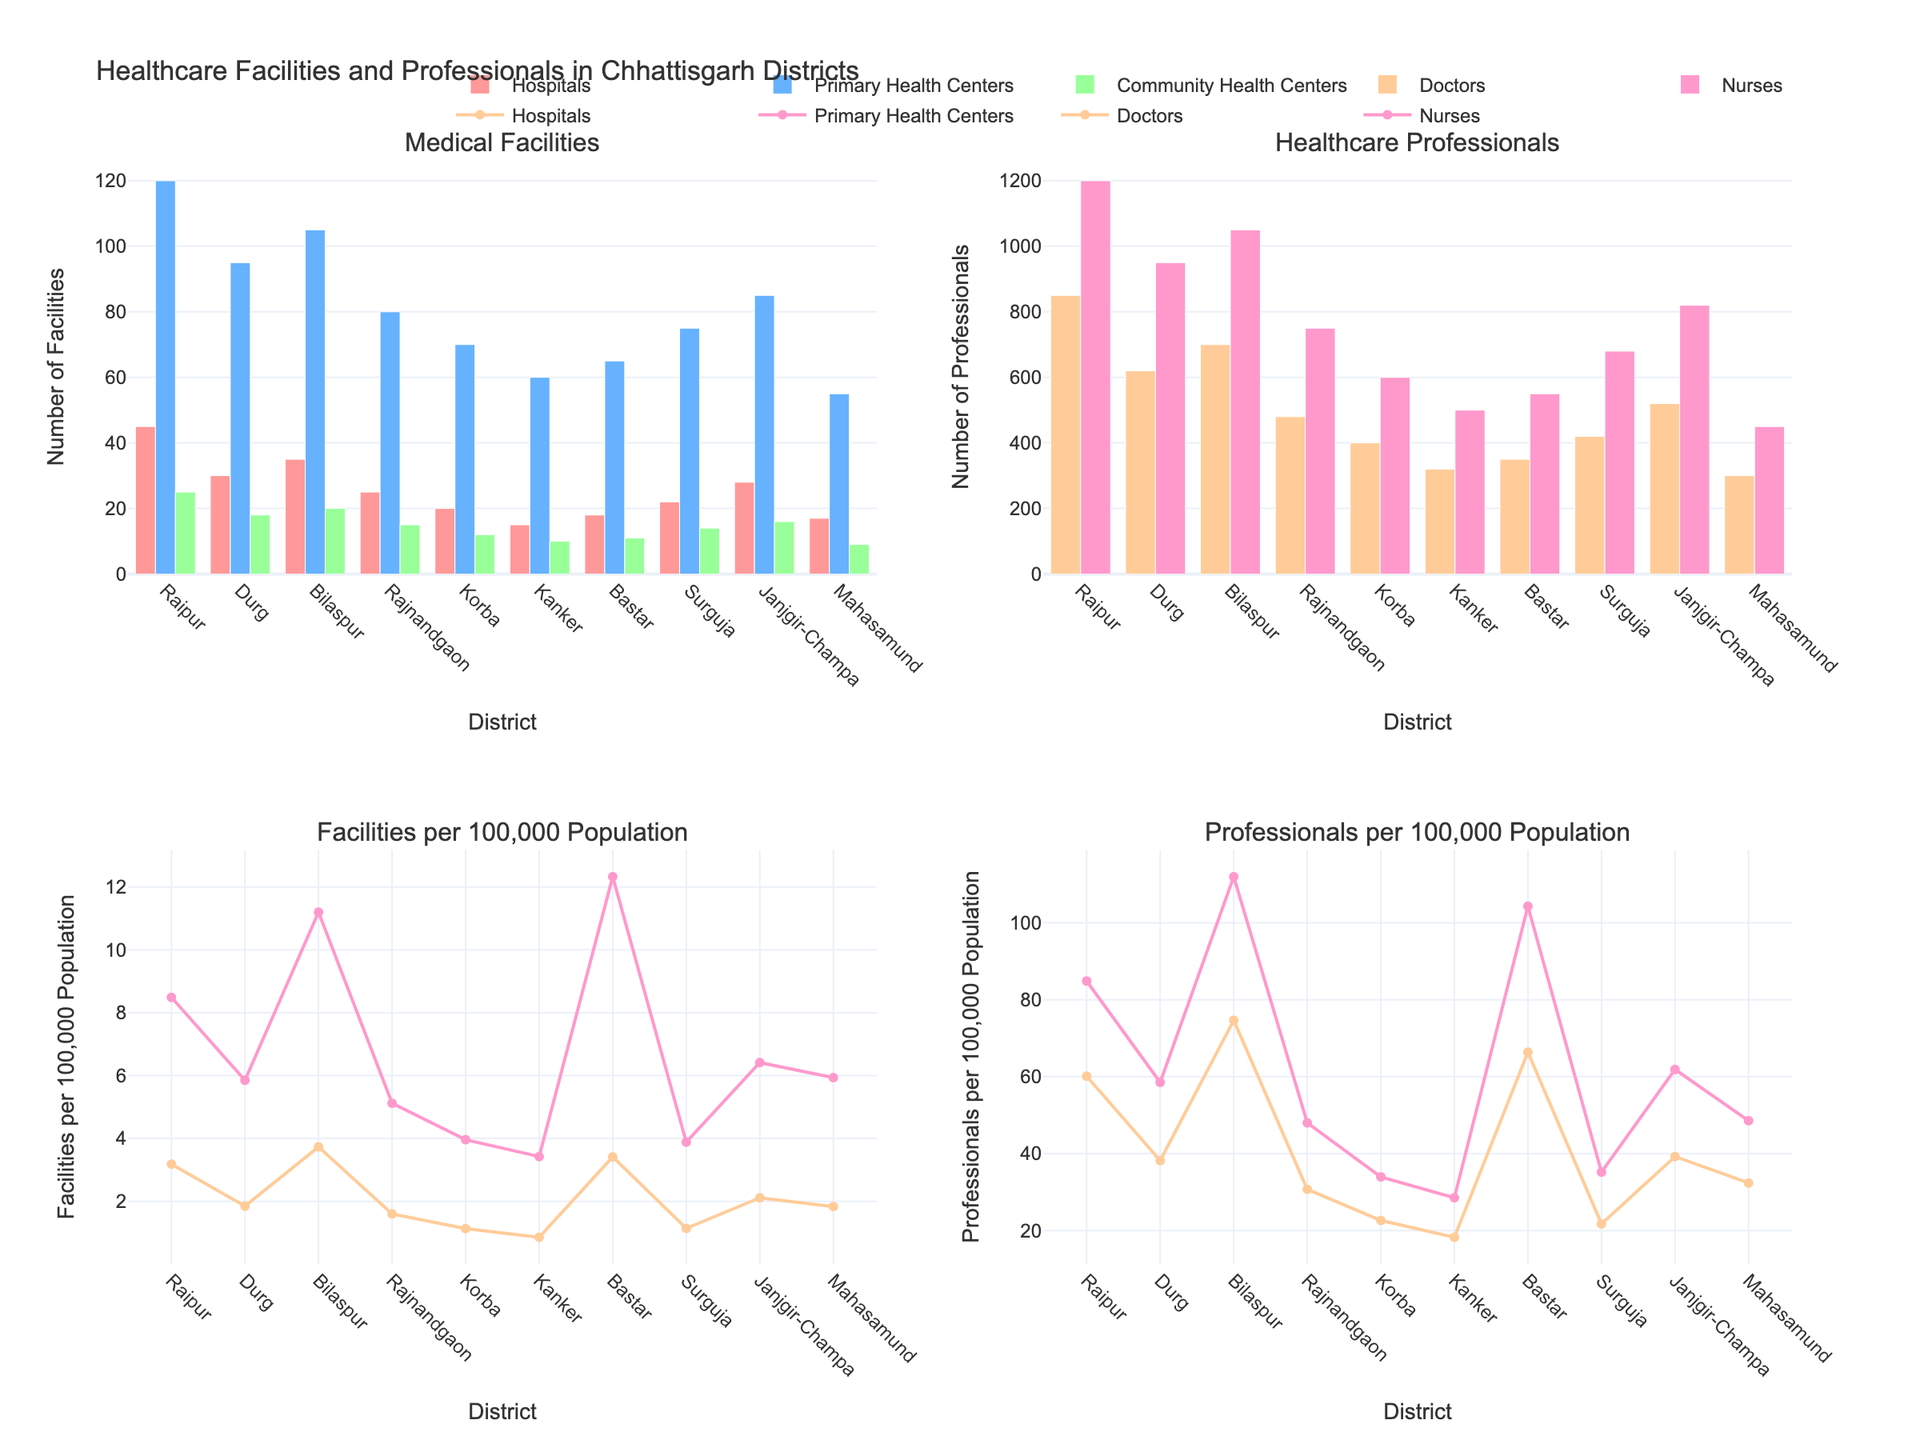What is the title of the figure? The title is located at the top of the figure. It is meant to give an overview of what the figure displays. In this case, it is clearly written at the top.
Answer: Healthcare Facilities and Professionals in Chhattisgarh Districts How many subplots are there in the figure? The figure is divided into sections, each representing a subplot. There are a total of four subplots, as indicated by the distinct sections within the figure.
Answer: 4 Which district has the highest number of hospitals? Look at the first subplot titled "Medical Facilities". Locate the highest bar in the "Hospitals" category. Raipur has the highest bar.
Answer: Raipur What is the color used for Primary Health Centers in the Medical Facilities subplot? In the first subplot, each type of facility has a different color. Primary Health Centers are represented in blue.
Answer: Blue How many doctors are there in Bilaspur? Refer to the second subplot titled "Healthcare Professionals". The bar representing Bilaspur in the "Doctors" category will tell you the number.
Answer: 700 Which district has the lowest number of Community Health Centers? In the first subplot, identify the smallest bar in the "Community Health Centers" category. Mahasamund has the smallest bar.
Answer: Mahasamund Compare the number of nurses in Kanker and Bastar. Which district has more nurses? Look at the second subplot titled "Healthcare Professionals". Compare the bars for Kanker and Bastar in the "Nurses" category. Bastar has a higher bar.
Answer: Bastar What is the average number of hospitals in Raipur, Durg, and Bilaspur? Sum the number of hospitals in Raipur, Durg, and Bilaspur. Then divide by 3. (45 + 30 + 35) / 3 = 110 / 3
Answer: 36.67 Which district has the highest number of healthcare professionals per 100,000 population? Refer to the fourth subplot and identify the district with the highest point or line in the plot. You need to locate the peak value in the right-hand plot.
Answer: Raipur How many districts have more than 15 Primary Health Centers? In the first subplot titled "Medical Facilities", count the number of districts where the height of the bars for Primary Health Centers exceeds the 15-mark.
Answer: 10 